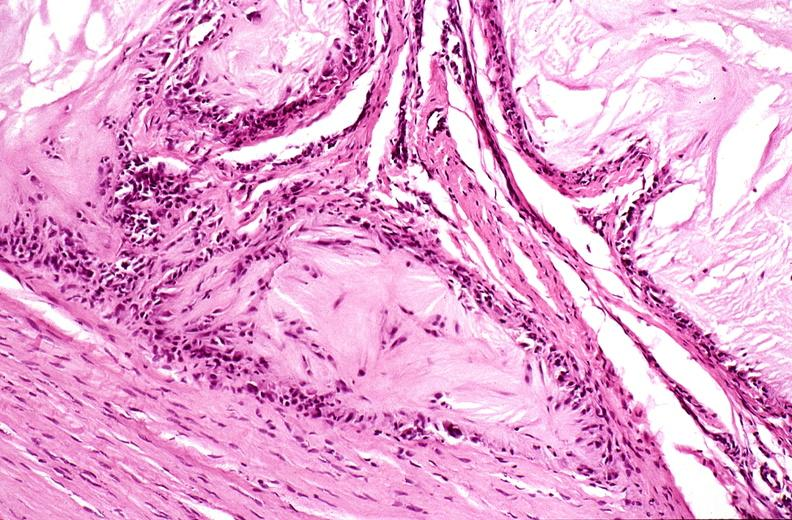what is present?
Answer the question using a single word or phrase. Joints 